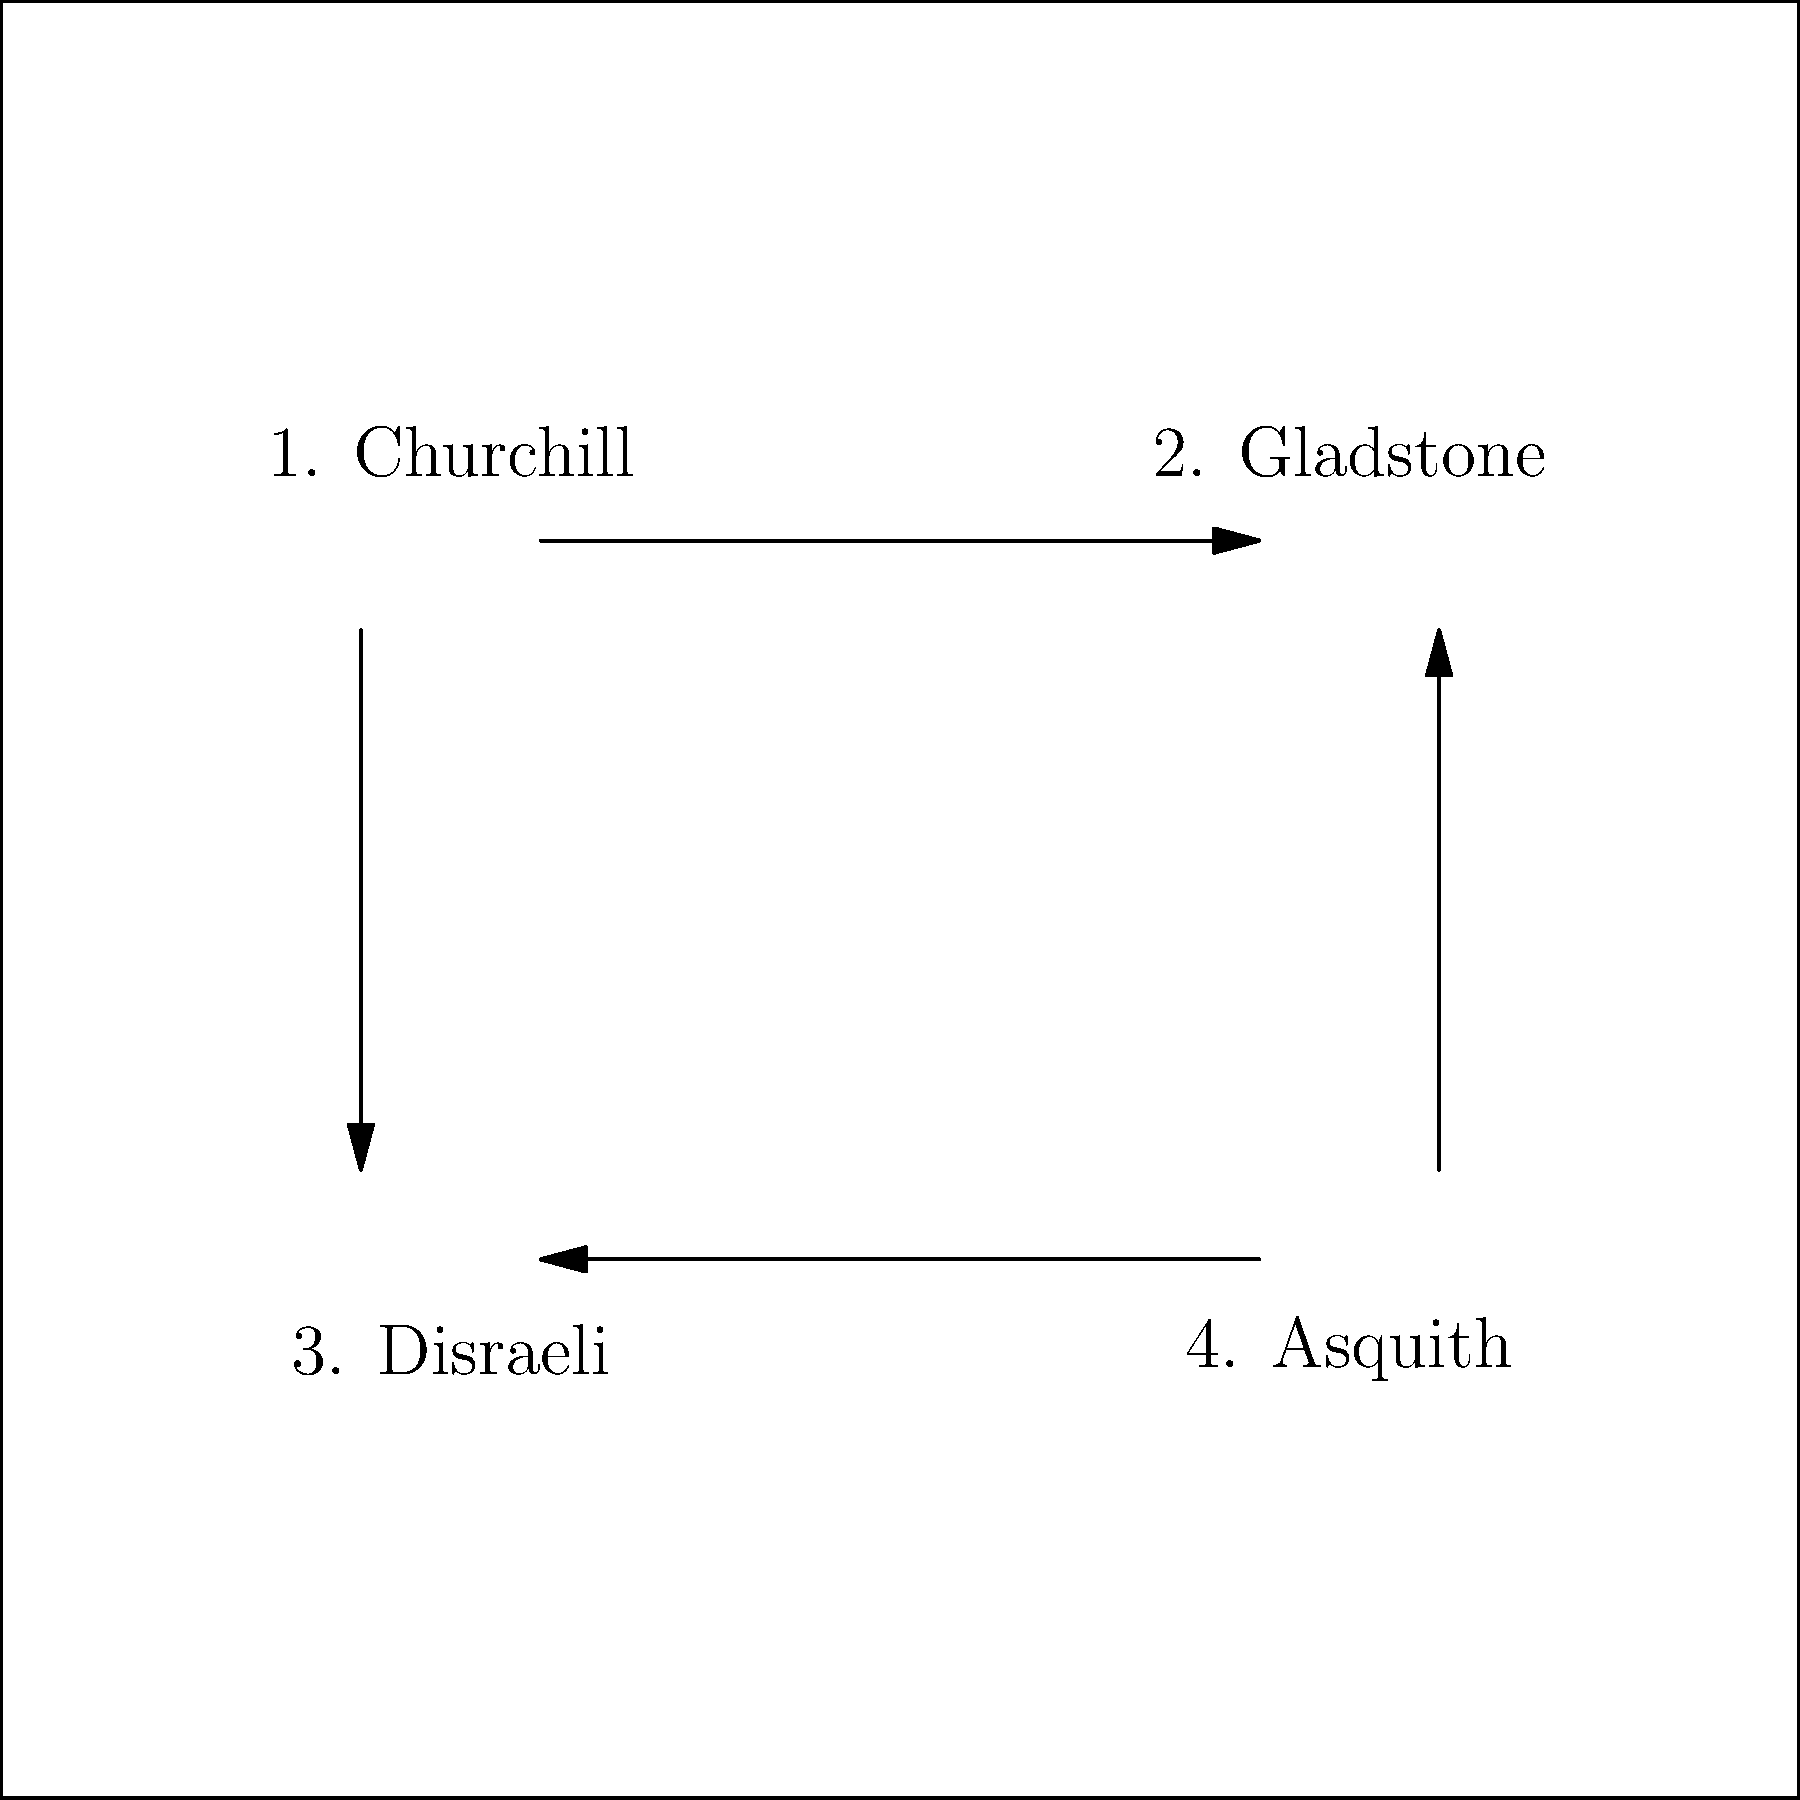In a newly discovered painting of the Oxford Debating Society, four prominent British Prime Ministers are depicted: Churchill, Gladstone, Disraeli, and Asquith. The curator wishes to rearrange their positions in the painting using only permutations that swap two figures at a time. If the desired arrangement is (Gladstone, Churchill, Asquith, Disraeli), what is the order of the permutation group element needed to achieve this from the original arrangement shown in the diagram? Let's approach this step-by-step:

1) First, we need to understand the initial and desired arrangements:
   Initial: (Churchill, Gladstone, Disraeli, Asquith)
   Desired: (Gladstone, Churchill, Asquith, Disraeli)

2) In cycle notation, we can represent this permutation as $(1 2)(3 4)$, where:
   - $(1 2)$ swaps Churchill and Gladstone
   - $(3 4)$ swaps Disraeli and Asquith

3) The order of a permutation is the least common multiple (LCM) of the lengths of its disjoint cycles.

4) In this case, we have two disjoint cycles, each of length 2.

5) The LCM of 2 and 2 is 2.

6) Therefore, the order of this permutation is 2.

This means that applying this permutation twice would return the figures to their original positions, which is a characteristic of elements of order 2 in a permutation group.
Answer: 2 